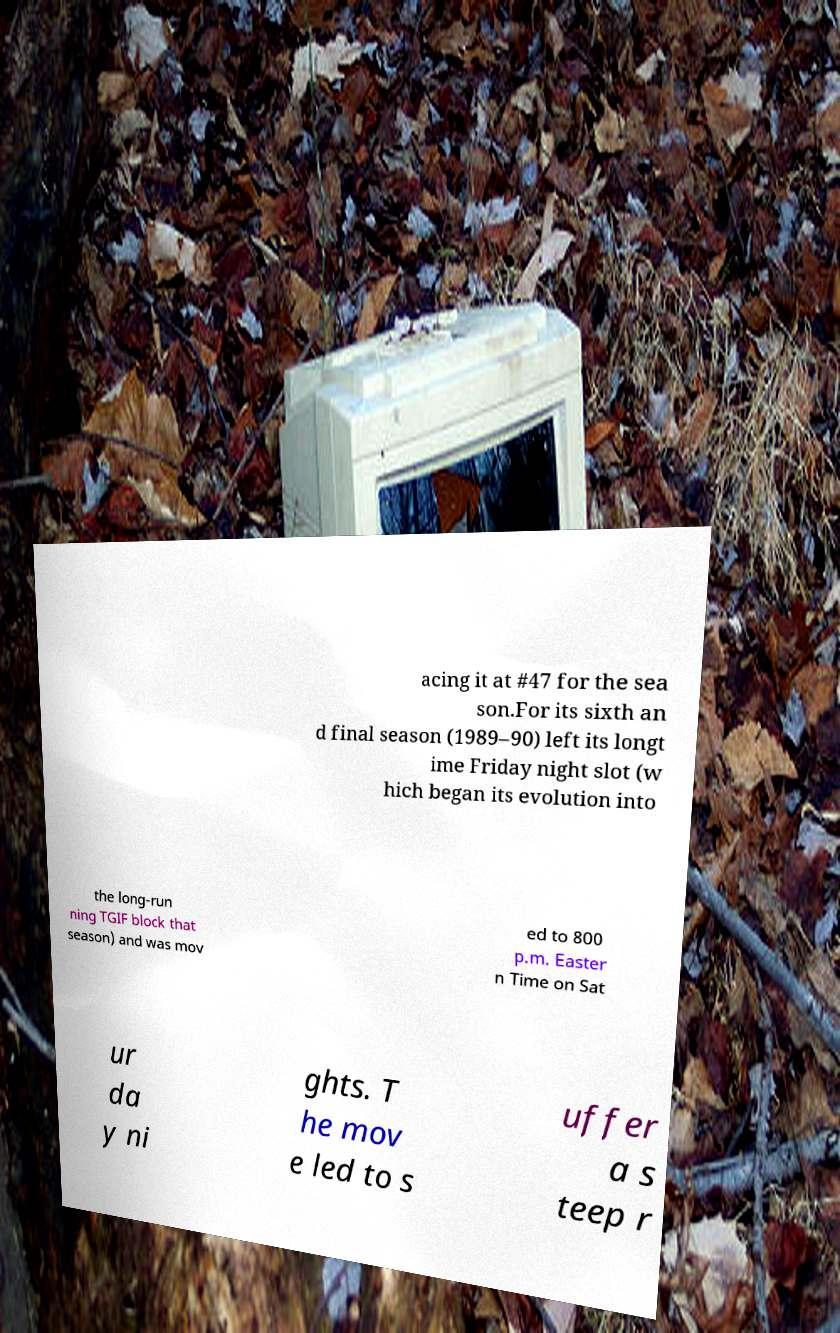There's text embedded in this image that I need extracted. Can you transcribe it verbatim? acing it at #47 for the sea son.For its sixth an d final season (1989–90) left its longt ime Friday night slot (w hich began its evolution into the long-run ning TGIF block that season) and was mov ed to 800 p.m. Easter n Time on Sat ur da y ni ghts. T he mov e led to s uffer a s teep r 